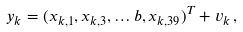Convert formula to latex. <formula><loc_0><loc_0><loc_500><loc_500>y _ { k } = ( x _ { k , 1 } , x _ { k , 3 } , \dots b , x _ { k , 3 9 } ) ^ { T } + v _ { k } \, ,</formula> 